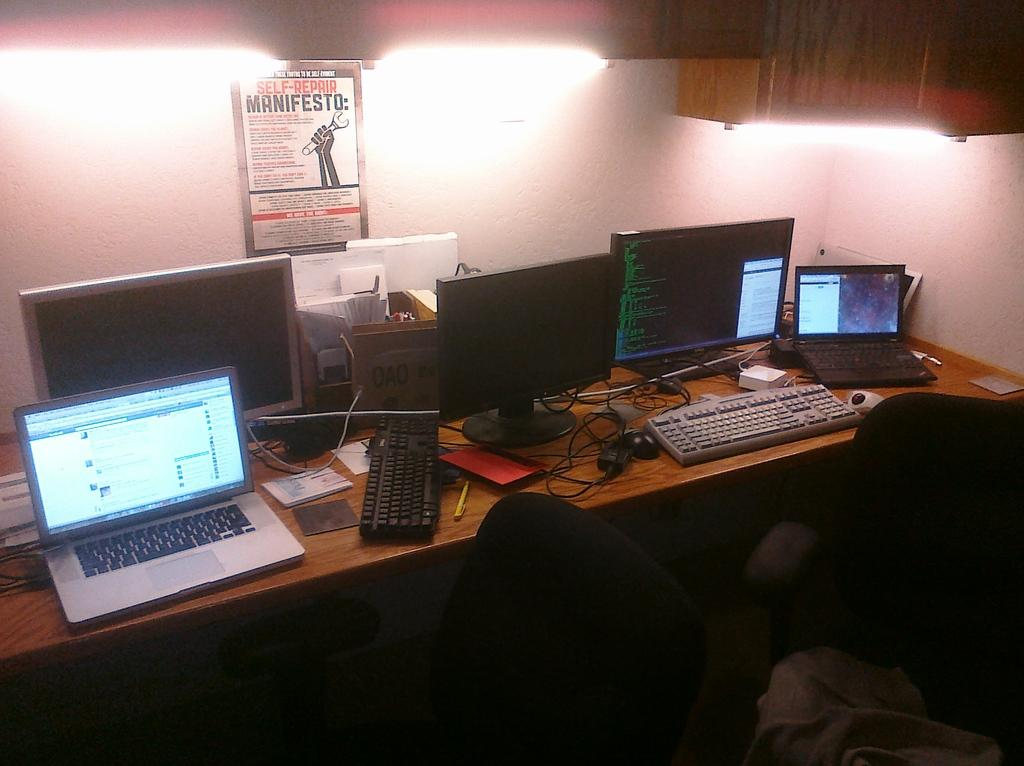What type of furniture is present in the image? There are chairs and tables in the image. What electronic devices can be seen on the tables? There are laptops, monitors, keyboards, mice, and cables on the tables. What stationary items are on the tables? There is a book and a pen on the tables. What can be seen in the background of the image? There is a poster, a wall, and lights in the background. Can you see any ghosts in the image? There are no ghosts present in the image. How does the elbow of the person using the laptop look like in the image? There is no person visible in the image, so it is impossible to describe their elbow. 